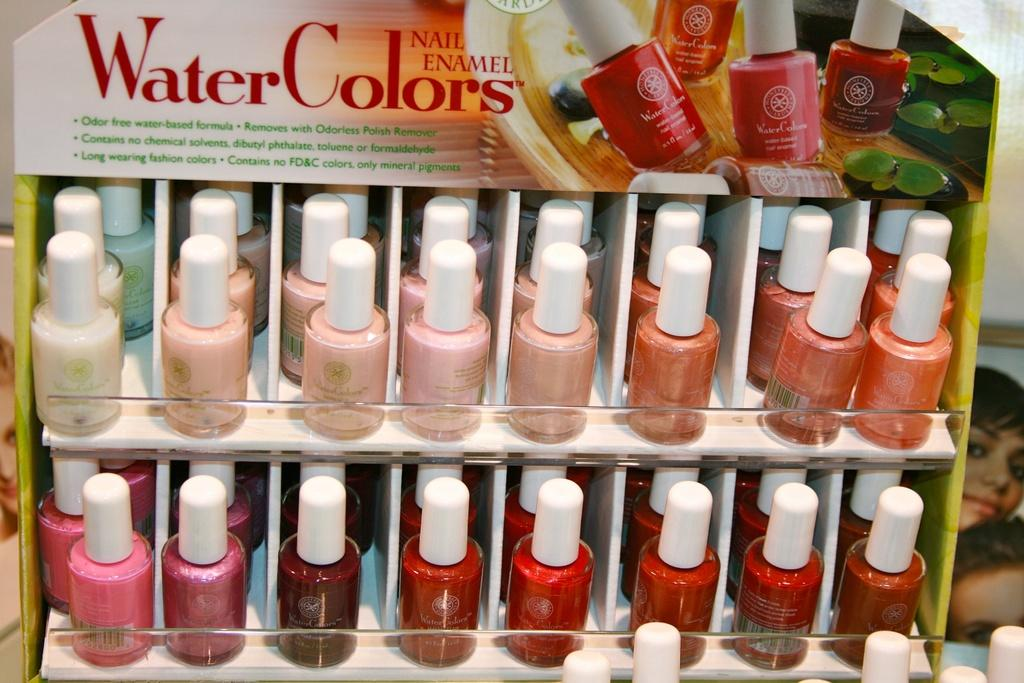What type of items are visible in the image? There are nail polish bottles in the image. How are the nail polish bottles organized in the image? The nail polish bottles are arranged in a rack. Who is the governor talking to in the image? There is no governor or conversation present in the image; it only features nail polish bottles arranged in a rack. 